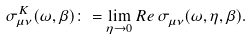Convert formula to latex. <formula><loc_0><loc_0><loc_500><loc_500>\sigma ^ { K } _ { \mu \nu } ( \omega , \beta ) \colon = & \lim _ { \eta \to 0 } R e \, \sigma ^ { \ } _ { \mu \nu } ( \omega , \eta , \beta ) .</formula> 